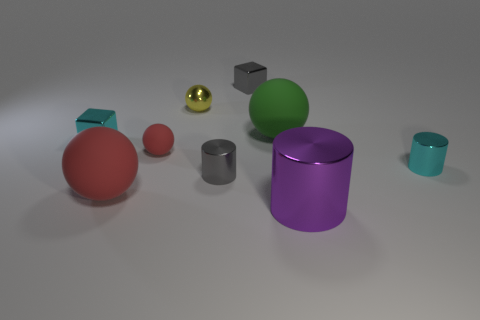Are there fewer large green cylinders than gray blocks?
Offer a terse response. Yes. There is a sphere that is on the right side of the tiny gray thing that is in front of the green rubber thing; what number of things are on the left side of it?
Provide a succinct answer. 6. There is a rubber ball right of the tiny red rubber thing; how big is it?
Offer a very short reply. Large. Does the red rubber object that is behind the big red thing have the same shape as the big green rubber thing?
Give a very brief answer. Yes. There is a green thing that is the same shape as the big red rubber object; what is it made of?
Your answer should be very brief. Rubber. Are there any other things that have the same size as the cyan shiny block?
Your answer should be very brief. Yes. Are any big yellow rubber cubes visible?
Ensure brevity in your answer.  No. The tiny red sphere in front of the cyan thing that is left of the cyan metal thing to the right of the big metallic object is made of what material?
Your answer should be very brief. Rubber. There is a big green rubber object; does it have the same shape as the tiny object that is behind the shiny ball?
Your answer should be compact. No. What number of tiny shiny objects are the same shape as the large metallic thing?
Offer a terse response. 2. 